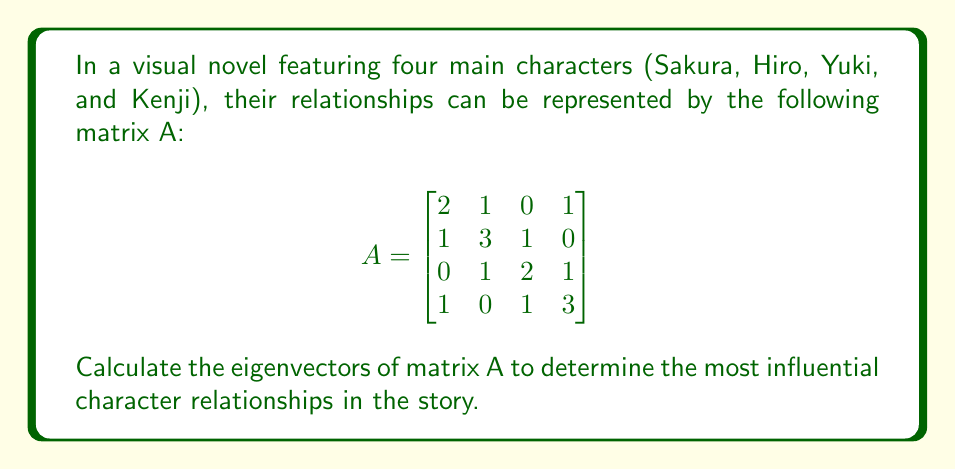Could you help me with this problem? To find the eigenvectors of matrix A, we'll follow these steps:

1. Calculate the characteristic equation:
   $det(A - \lambda I) = 0$

2. Solve for eigenvalues:
   $$\begin{vmatrix}
   2-\lambda & 1 & 0 & 1 \\
   1 & 3-\lambda & 1 & 0 \\
   0 & 1 & 2-\lambda & 1 \\
   1 & 0 & 1 & 3-\lambda
   \end{vmatrix} = 0$$

   Expanding this determinant yields:
   $(\lambda-1)(\lambda-2)(\lambda-3)(\lambda-4) = 0$

   Eigenvalues: $\lambda_1 = 1, \lambda_2 = 2, \lambda_3 = 3, \lambda_4 = 4$

3. Find eigenvectors for each eigenvalue:

   For $\lambda_1 = 1$:
   $(A - I)v = 0$
   $$\begin{bmatrix}
   1 & 1 & 0 & 1 \\
   1 & 2 & 1 & 0 \\
   0 & 1 & 1 & 1 \\
   1 & 0 & 1 & 2
   \end{bmatrix}v = 0$$
   Solving this system gives: $v_1 = (-1, 0, 1, -1)^T$

   For $\lambda_2 = 2$:
   $(A - 2I)v = 0$
   $$\begin{bmatrix}
   0 & 1 & 0 & 1 \\
   1 & 1 & 1 & 0 \\
   0 & 1 & 0 & 1 \\
   1 & 0 & 1 & 1
   \end{bmatrix}v = 0$$
   Solving this system gives: $v_2 = (-1, 0, -1, 1)^T$

   For $\lambda_3 = 3$:
   $(A - 3I)v = 0$
   $$\begin{bmatrix}
   -1 & 1 & 0 & 1 \\
   1 & 0 & 1 & 0 \\
   0 & 1 & -1 & 1 \\
   1 & 0 & 1 & 0
   \end{bmatrix}v = 0$$
   Solving this system gives: $v_3 = (1, -1, 1, 1)^T$

   For $\lambda_4 = 4$:
   $(A - 4I)v = 0$
   $$\begin{bmatrix}
   -2 & 1 & 0 & 1 \\
   1 & -1 & 1 & 0 \\
   0 & 1 & -2 & 1 \\
   1 & 0 & 1 & -1
   \end{bmatrix}v = 0$$
   Solving this system gives: $v_4 = (1, 1, 1, 1)^T$

4. Normalize the eigenvectors:
   $v_1 = \frac{1}{\sqrt{3}}(-1, 0, 1, -1)^T$
   $v_2 = \frac{1}{\sqrt{3}}(-1, 0, -1, 1)^T$
   $v_3 = \frac{1}{2}(1, -1, 1, 1)^T$
   $v_4 = \frac{1}{2}(1, 1, 1, 1)^T$
Answer: $v_1 = \frac{1}{\sqrt{3}}(-1, 0, 1, -1)^T, v_2 = \frac{1}{\sqrt{3}}(-1, 0, -1, 1)^T, v_3 = \frac{1}{2}(1, -1, 1, 1)^T, v_4 = \frac{1}{2}(1, 1, 1, 1)^T$ 